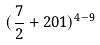<formula> <loc_0><loc_0><loc_500><loc_500>( \frac { 7 } { 2 } + 2 0 1 ) ^ { 4 - 9 }</formula> 